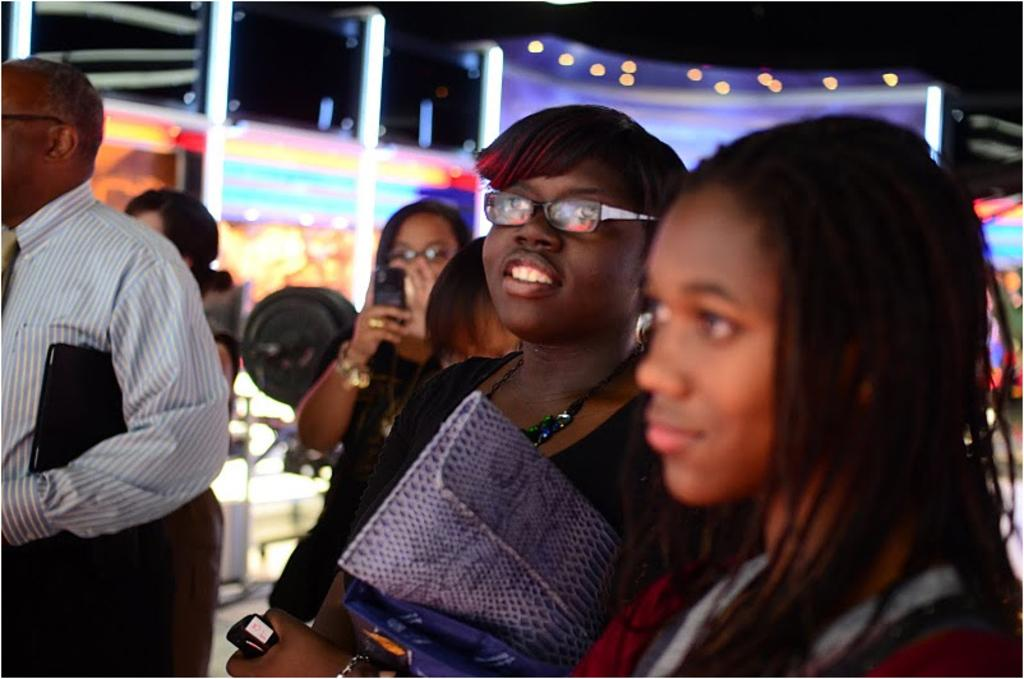How many people are present in the image? There are six people in the image, including five women and one man. Can you describe the lighting in the background of the image? The lighting in the background of the image is not specified, but it is mentioned that there is a lighting present. What type of berry is being used as toothpaste by the women in the image? There is no mention of berries or toothpaste in the image, so this question cannot be answered. 